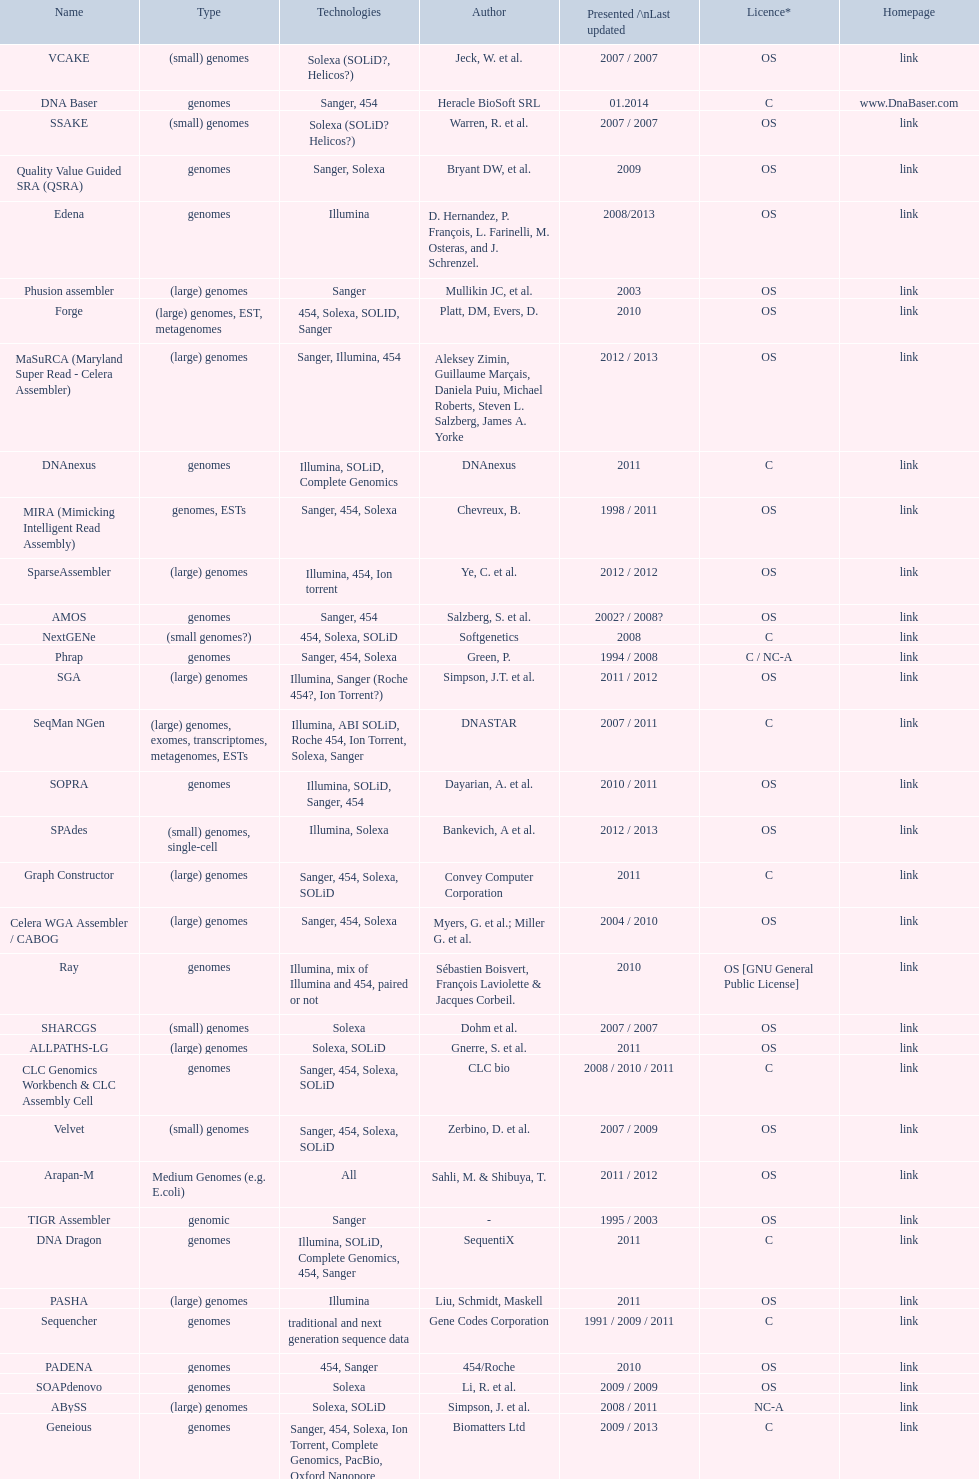What is the total number of assemblers supporting small genomes type technologies? 9. 